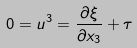Convert formula to latex. <formula><loc_0><loc_0><loc_500><loc_500>0 = u ^ { 3 } = \frac { \partial \xi } { \partial x _ { 3 } } + \tau</formula> 